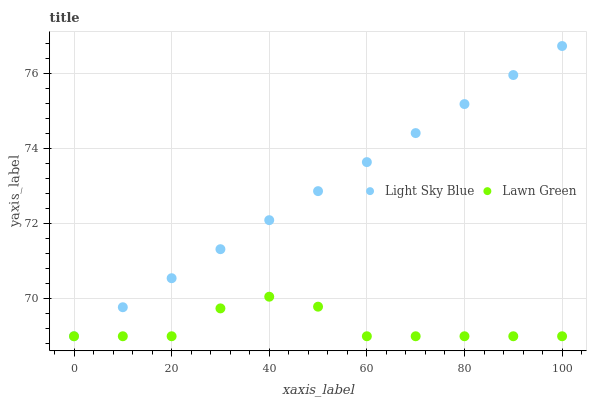Does Lawn Green have the minimum area under the curve?
Answer yes or no. Yes. Does Light Sky Blue have the maximum area under the curve?
Answer yes or no. Yes. Does Light Sky Blue have the minimum area under the curve?
Answer yes or no. No. Is Light Sky Blue the smoothest?
Answer yes or no. Yes. Is Lawn Green the roughest?
Answer yes or no. Yes. Is Light Sky Blue the roughest?
Answer yes or no. No. Does Lawn Green have the lowest value?
Answer yes or no. Yes. Does Light Sky Blue have the highest value?
Answer yes or no. Yes. Does Light Sky Blue intersect Lawn Green?
Answer yes or no. Yes. Is Light Sky Blue less than Lawn Green?
Answer yes or no. No. Is Light Sky Blue greater than Lawn Green?
Answer yes or no. No. 